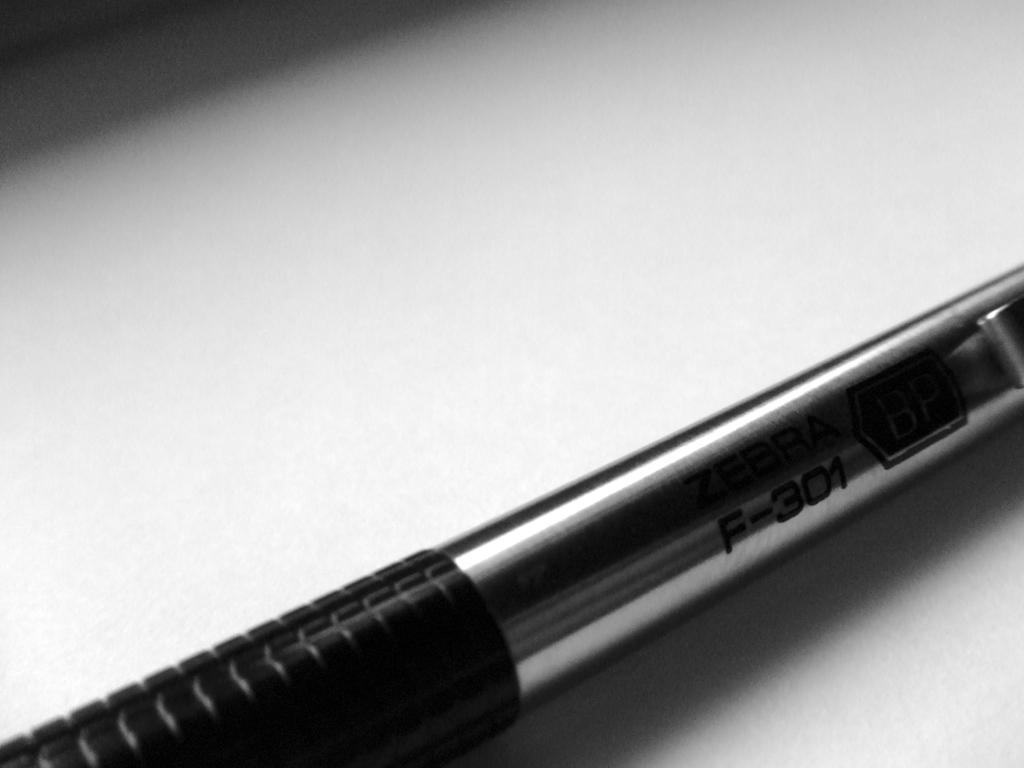Please provide a concise description of this image. In this image I can see a pen in black and gray color and the pen is on the white color surface. 